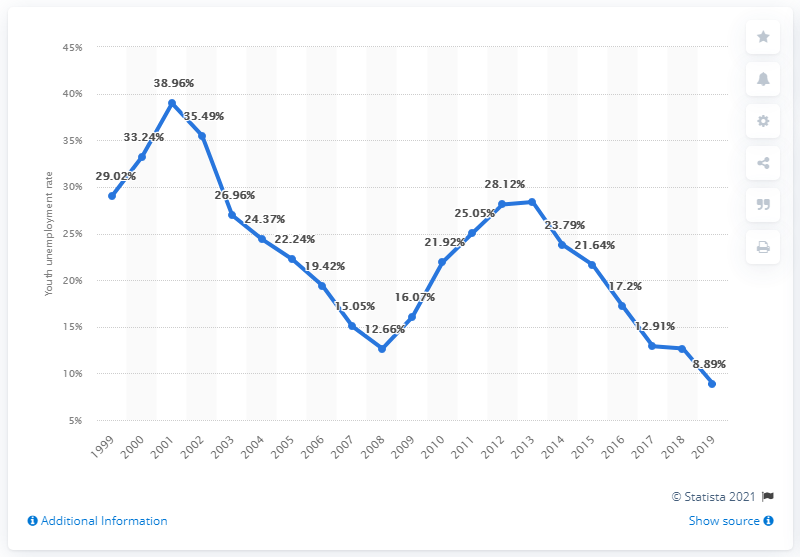Draw attention to some important aspects in this diagram. The youth unemployment rate in Bulgaria in 2019 was 8.89%. 